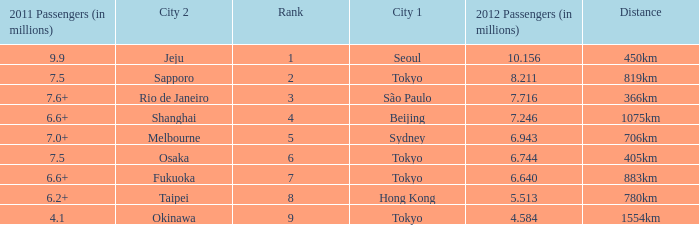How many passengers (in millions) flew through along the route that is 1075km long in 2012? 7.246. 